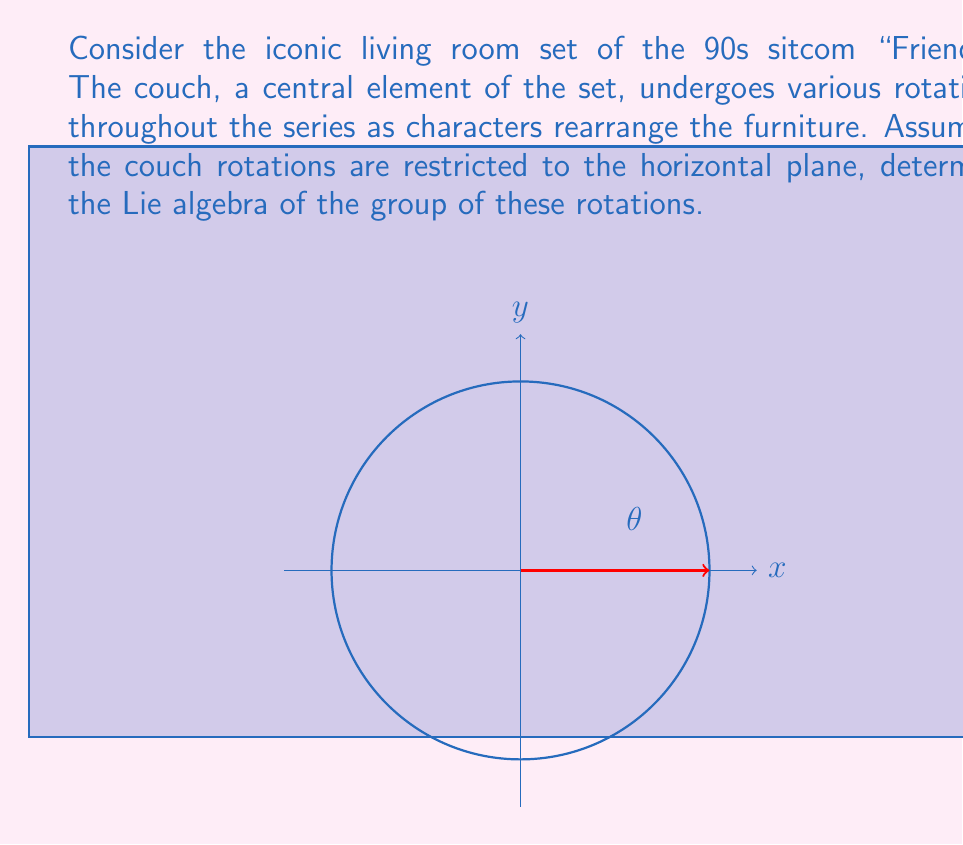Help me with this question. Let's approach this step-by-step:

1) The group of rotations in a 2D plane is the special orthogonal group $SO(2)$. This group represents all rotations around the origin in two-dimensional Euclidean space.

2) To find the Lie algebra of $SO(2)$, we need to consider infinitesimal rotations. These are rotations by very small angles.

3) A rotation matrix in $SO(2)$ can be represented as:

   $$R(\theta) = \begin{pmatrix} \cos\theta & -\sin\theta \\ \sin\theta & \cos\theta \end{pmatrix}$$

4) For small angles $\theta$, we can approximate:
   $\cos\theta \approx 1$
   $\sin\theta \approx \theta$

5) Substituting these approximations:

   $$R(\theta) \approx \begin{pmatrix} 1 & -\theta \\ \theta & 1 \end{pmatrix} = I + \theta \begin{pmatrix} 0 & -1 \\ 1 & 0 \end{pmatrix}$$

6) The matrix $\begin{pmatrix} 0 & -1 \\ 1 & 0 \end{pmatrix}$ is the generator of rotations, which we'll call $J$.

7) The Lie algebra $\mathfrak{so}(2)$ consists of all real scalar multiples of $J$:

   $$\mathfrak{so}(2) = \left\{ \theta J \mid \theta \in \mathbb{R} \right\}$$

8) This is a one-dimensional vector space over the real numbers, isomorphic to $\mathbb{R}$.

Thus, the Lie algebra of the group of couch rotations in the "Friends" living room is isomorphic to the real line $\mathbb{R}$.
Answer: $\mathfrak{so}(2) \cong \mathbb{R}$ 